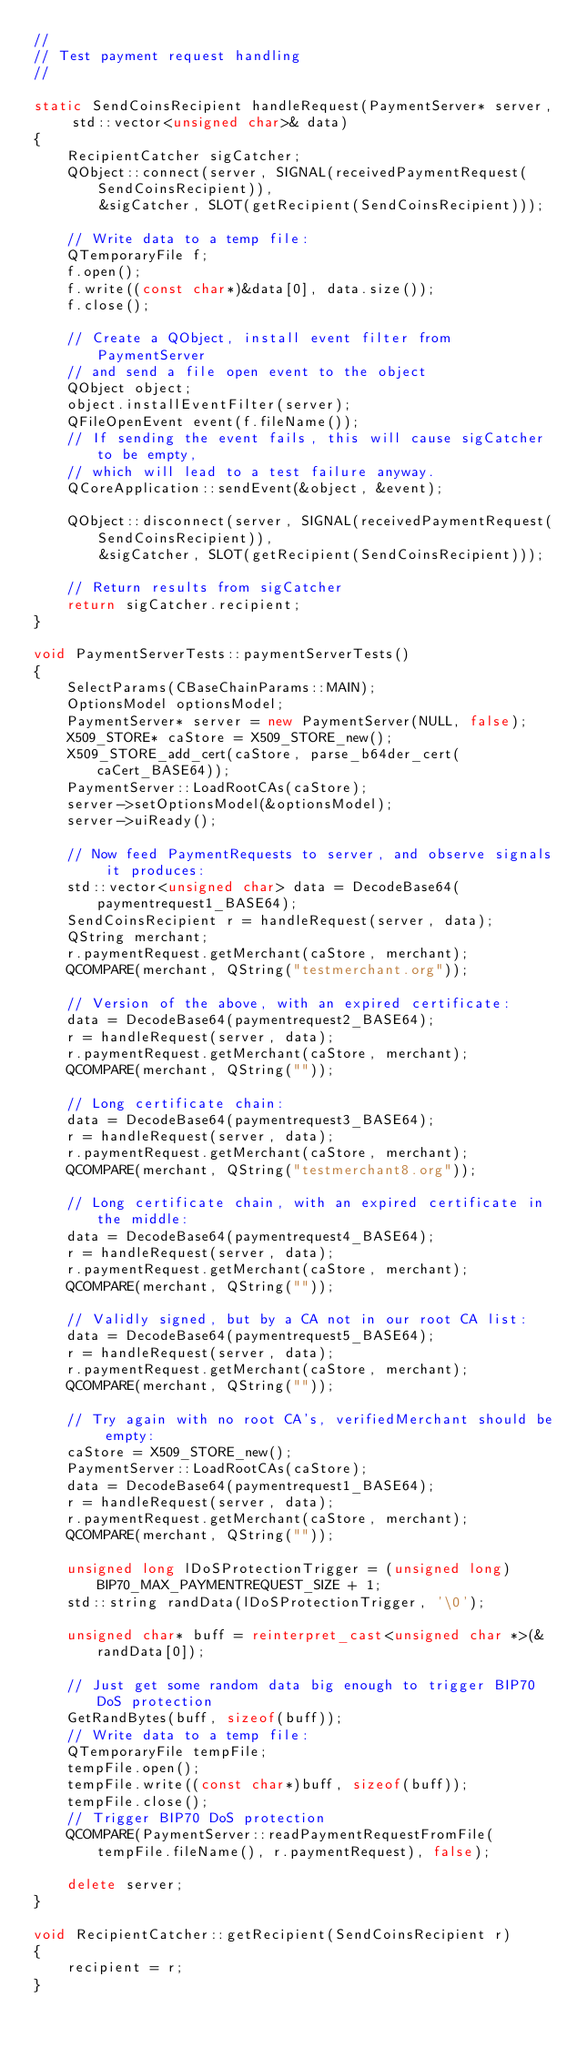Convert code to text. <code><loc_0><loc_0><loc_500><loc_500><_C++_>//
// Test payment request handling
//

static SendCoinsRecipient handleRequest(PaymentServer* server, std::vector<unsigned char>& data)
{
    RecipientCatcher sigCatcher;
    QObject::connect(server, SIGNAL(receivedPaymentRequest(SendCoinsRecipient)),
        &sigCatcher, SLOT(getRecipient(SendCoinsRecipient)));

    // Write data to a temp file:
    QTemporaryFile f;
    f.open();
    f.write((const char*)&data[0], data.size());
    f.close();

    // Create a QObject, install event filter from PaymentServer
    // and send a file open event to the object
    QObject object;
    object.installEventFilter(server);
    QFileOpenEvent event(f.fileName());
    // If sending the event fails, this will cause sigCatcher to be empty,
    // which will lead to a test failure anyway.
    QCoreApplication::sendEvent(&object, &event);

    QObject::disconnect(server, SIGNAL(receivedPaymentRequest(SendCoinsRecipient)),
        &sigCatcher, SLOT(getRecipient(SendCoinsRecipient)));

    // Return results from sigCatcher
    return sigCatcher.recipient;
}

void PaymentServerTests::paymentServerTests()
{
    SelectParams(CBaseChainParams::MAIN);
    OptionsModel optionsModel;
    PaymentServer* server = new PaymentServer(NULL, false);
    X509_STORE* caStore = X509_STORE_new();
    X509_STORE_add_cert(caStore, parse_b64der_cert(caCert_BASE64));
    PaymentServer::LoadRootCAs(caStore);
    server->setOptionsModel(&optionsModel);
    server->uiReady();

    // Now feed PaymentRequests to server, and observe signals it produces:
    std::vector<unsigned char> data = DecodeBase64(paymentrequest1_BASE64);
    SendCoinsRecipient r = handleRequest(server, data);
    QString merchant;
    r.paymentRequest.getMerchant(caStore, merchant);
    QCOMPARE(merchant, QString("testmerchant.org"));

    // Version of the above, with an expired certificate:
    data = DecodeBase64(paymentrequest2_BASE64);
    r = handleRequest(server, data);
    r.paymentRequest.getMerchant(caStore, merchant);
    QCOMPARE(merchant, QString(""));

    // Long certificate chain:
    data = DecodeBase64(paymentrequest3_BASE64);
    r = handleRequest(server, data);
    r.paymentRequest.getMerchant(caStore, merchant);
    QCOMPARE(merchant, QString("testmerchant8.org"));

    // Long certificate chain, with an expired certificate in the middle:
    data = DecodeBase64(paymentrequest4_BASE64);
    r = handleRequest(server, data);
    r.paymentRequest.getMerchant(caStore, merchant);
    QCOMPARE(merchant, QString(""));

    // Validly signed, but by a CA not in our root CA list:
    data = DecodeBase64(paymentrequest5_BASE64);
    r = handleRequest(server, data);
    r.paymentRequest.getMerchant(caStore, merchant);
    QCOMPARE(merchant, QString(""));

    // Try again with no root CA's, verifiedMerchant should be empty:
    caStore = X509_STORE_new();
    PaymentServer::LoadRootCAs(caStore);
    data = DecodeBase64(paymentrequest1_BASE64);
    r = handleRequest(server, data);
    r.paymentRequest.getMerchant(caStore, merchant);
    QCOMPARE(merchant, QString(""));

    unsigned long lDoSProtectionTrigger = (unsigned long) BIP70_MAX_PAYMENTREQUEST_SIZE + 1;
    std::string randData(lDoSProtectionTrigger, '\0');

    unsigned char* buff = reinterpret_cast<unsigned char *>(&randData[0]);

    // Just get some random data big enough to trigger BIP70 DoS protection
    GetRandBytes(buff, sizeof(buff));
    // Write data to a temp file:
    QTemporaryFile tempFile;
    tempFile.open();
    tempFile.write((const char*)buff, sizeof(buff));
    tempFile.close();
    // Trigger BIP70 DoS protection
    QCOMPARE(PaymentServer::readPaymentRequestFromFile(tempFile.fileName(), r.paymentRequest), false);

    delete server;
}

void RecipientCatcher::getRecipient(SendCoinsRecipient r)
{
    recipient = r;
}
</code> 